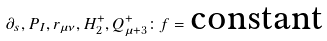<formula> <loc_0><loc_0><loc_500><loc_500>\partial _ { s } , P _ { I } , r _ { \mu \nu } , H _ { 2 } ^ { + } , Q _ { \mu + 3 } ^ { + } \colon f = \text {constant}</formula> 